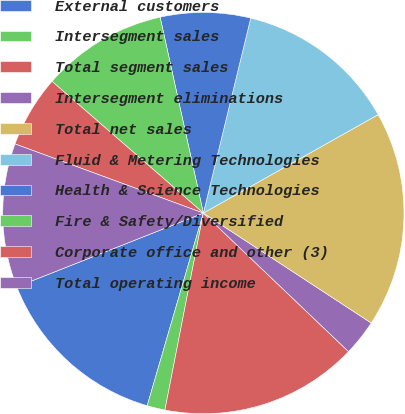Convert chart to OTSL. <chart><loc_0><loc_0><loc_500><loc_500><pie_chart><fcel>External customers<fcel>Intersegment sales<fcel>Total segment sales<fcel>Intersegment eliminations<fcel>Total net sales<fcel>Fluid & Metering Technologies<fcel>Health & Science Technologies<fcel>Fire & Safety/Diversified<fcel>Corporate office and other (3)<fcel>Total operating income<nl><fcel>14.49%<fcel>1.45%<fcel>15.94%<fcel>2.9%<fcel>17.39%<fcel>13.04%<fcel>7.25%<fcel>10.14%<fcel>5.8%<fcel>11.59%<nl></chart> 